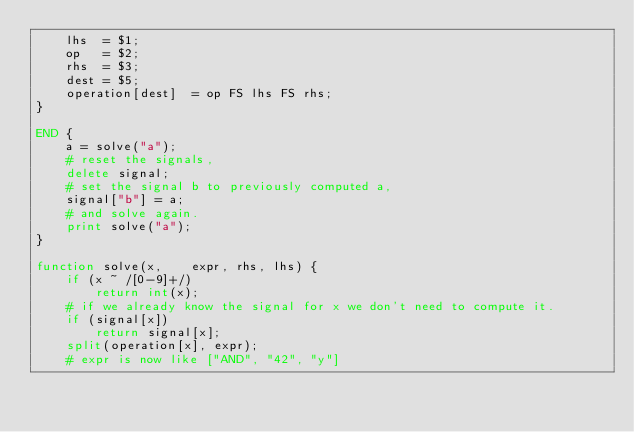Convert code to text. <code><loc_0><loc_0><loc_500><loc_500><_Awk_>	lhs  = $1;
	op   = $2;
	rhs  = $3;
	dest = $5;
	operation[dest]  = op FS lhs FS rhs;
}

END {
	a = solve("a");
	# reset the signals,
	delete signal;
	# set the signal b to previously computed a,
	signal["b"] = a;
	# and solve again.
	print solve("a");
}

function solve(x,    expr, rhs, lhs) {
	if (x ~ /[0-9]+/)
		return int(x);
	# if we already know the signal for x we don't need to compute it.
	if (signal[x])
		return signal[x];
	split(operation[x], expr);
	# expr is now like ["AND", "42", "y"]</code> 